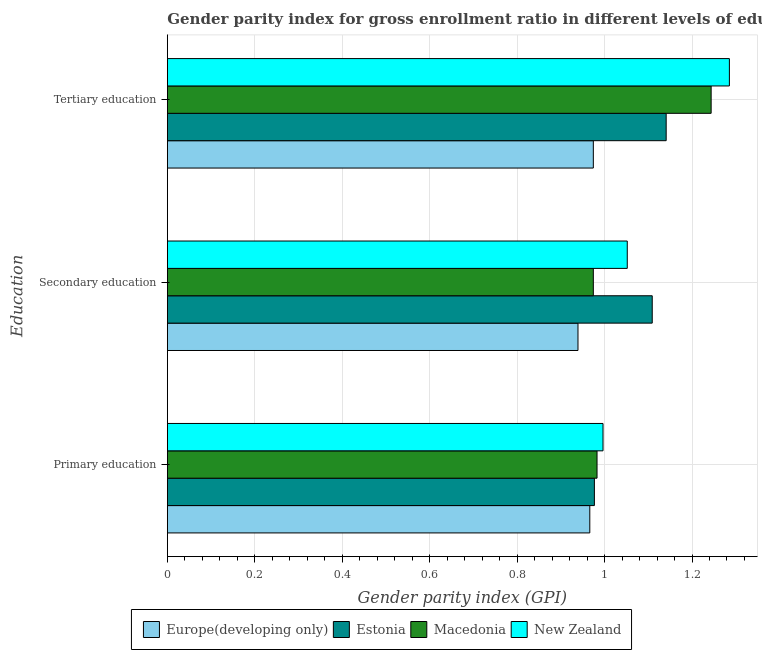Are the number of bars per tick equal to the number of legend labels?
Give a very brief answer. Yes. How many bars are there on the 3rd tick from the top?
Provide a short and direct response. 4. How many bars are there on the 1st tick from the bottom?
Your response must be concise. 4. What is the label of the 2nd group of bars from the top?
Give a very brief answer. Secondary education. What is the gender parity index in tertiary education in New Zealand?
Your response must be concise. 1.29. Across all countries, what is the maximum gender parity index in secondary education?
Your answer should be compact. 1.11. Across all countries, what is the minimum gender parity index in tertiary education?
Give a very brief answer. 0.97. In which country was the gender parity index in primary education maximum?
Provide a short and direct response. New Zealand. In which country was the gender parity index in secondary education minimum?
Your answer should be compact. Europe(developing only). What is the total gender parity index in primary education in the graph?
Provide a succinct answer. 3.92. What is the difference between the gender parity index in tertiary education in Estonia and that in New Zealand?
Ensure brevity in your answer.  -0.14. What is the difference between the gender parity index in primary education in Macedonia and the gender parity index in secondary education in Estonia?
Give a very brief answer. -0.13. What is the average gender parity index in secondary education per country?
Offer a terse response. 1.02. What is the difference between the gender parity index in secondary education and gender parity index in primary education in Estonia?
Give a very brief answer. 0.13. What is the ratio of the gender parity index in primary education in Europe(developing only) to that in Macedonia?
Ensure brevity in your answer.  0.98. Is the gender parity index in tertiary education in Estonia less than that in New Zealand?
Give a very brief answer. Yes. What is the difference between the highest and the second highest gender parity index in primary education?
Your answer should be compact. 0.01. What is the difference between the highest and the lowest gender parity index in tertiary education?
Offer a terse response. 0.31. In how many countries, is the gender parity index in tertiary education greater than the average gender parity index in tertiary education taken over all countries?
Provide a succinct answer. 2. Is the sum of the gender parity index in secondary education in Europe(developing only) and Estonia greater than the maximum gender parity index in primary education across all countries?
Give a very brief answer. Yes. What does the 2nd bar from the top in Tertiary education represents?
Provide a succinct answer. Macedonia. What does the 1st bar from the bottom in Tertiary education represents?
Your answer should be very brief. Europe(developing only). Is it the case that in every country, the sum of the gender parity index in primary education and gender parity index in secondary education is greater than the gender parity index in tertiary education?
Your answer should be compact. Yes. How many countries are there in the graph?
Your answer should be compact. 4. What is the difference between two consecutive major ticks on the X-axis?
Keep it short and to the point. 0.2. Are the values on the major ticks of X-axis written in scientific E-notation?
Your answer should be very brief. No. Does the graph contain grids?
Make the answer very short. Yes. How are the legend labels stacked?
Provide a succinct answer. Horizontal. What is the title of the graph?
Make the answer very short. Gender parity index for gross enrollment ratio in different levels of education in 1996. What is the label or title of the X-axis?
Offer a very short reply. Gender parity index (GPI). What is the label or title of the Y-axis?
Ensure brevity in your answer.  Education. What is the Gender parity index (GPI) of Europe(developing only) in Primary education?
Your answer should be very brief. 0.97. What is the Gender parity index (GPI) of Estonia in Primary education?
Ensure brevity in your answer.  0.98. What is the Gender parity index (GPI) of Macedonia in Primary education?
Keep it short and to the point. 0.98. What is the Gender parity index (GPI) of New Zealand in Primary education?
Ensure brevity in your answer.  1. What is the Gender parity index (GPI) of Europe(developing only) in Secondary education?
Your response must be concise. 0.94. What is the Gender parity index (GPI) in Estonia in Secondary education?
Give a very brief answer. 1.11. What is the Gender parity index (GPI) in Macedonia in Secondary education?
Provide a succinct answer. 0.97. What is the Gender parity index (GPI) of New Zealand in Secondary education?
Your response must be concise. 1.05. What is the Gender parity index (GPI) in Europe(developing only) in Tertiary education?
Your response must be concise. 0.97. What is the Gender parity index (GPI) in Estonia in Tertiary education?
Your answer should be compact. 1.14. What is the Gender parity index (GPI) of Macedonia in Tertiary education?
Make the answer very short. 1.24. What is the Gender parity index (GPI) in New Zealand in Tertiary education?
Ensure brevity in your answer.  1.29. Across all Education, what is the maximum Gender parity index (GPI) in Europe(developing only)?
Make the answer very short. 0.97. Across all Education, what is the maximum Gender parity index (GPI) of Estonia?
Offer a very short reply. 1.14. Across all Education, what is the maximum Gender parity index (GPI) in Macedonia?
Offer a terse response. 1.24. Across all Education, what is the maximum Gender parity index (GPI) of New Zealand?
Offer a terse response. 1.29. Across all Education, what is the minimum Gender parity index (GPI) of Europe(developing only)?
Provide a succinct answer. 0.94. Across all Education, what is the minimum Gender parity index (GPI) in Estonia?
Offer a very short reply. 0.98. Across all Education, what is the minimum Gender parity index (GPI) in Macedonia?
Provide a short and direct response. 0.97. Across all Education, what is the minimum Gender parity index (GPI) in New Zealand?
Offer a terse response. 1. What is the total Gender parity index (GPI) in Europe(developing only) in the graph?
Provide a succinct answer. 2.88. What is the total Gender parity index (GPI) of Estonia in the graph?
Provide a short and direct response. 3.23. What is the total Gender parity index (GPI) of Macedonia in the graph?
Keep it short and to the point. 3.2. What is the total Gender parity index (GPI) of New Zealand in the graph?
Ensure brevity in your answer.  3.33. What is the difference between the Gender parity index (GPI) of Europe(developing only) in Primary education and that in Secondary education?
Ensure brevity in your answer.  0.03. What is the difference between the Gender parity index (GPI) in Estonia in Primary education and that in Secondary education?
Give a very brief answer. -0.13. What is the difference between the Gender parity index (GPI) of Macedonia in Primary education and that in Secondary education?
Keep it short and to the point. 0.01. What is the difference between the Gender parity index (GPI) of New Zealand in Primary education and that in Secondary education?
Your answer should be very brief. -0.06. What is the difference between the Gender parity index (GPI) in Europe(developing only) in Primary education and that in Tertiary education?
Keep it short and to the point. -0.01. What is the difference between the Gender parity index (GPI) in Estonia in Primary education and that in Tertiary education?
Your answer should be compact. -0.16. What is the difference between the Gender parity index (GPI) in Macedonia in Primary education and that in Tertiary education?
Ensure brevity in your answer.  -0.26. What is the difference between the Gender parity index (GPI) of New Zealand in Primary education and that in Tertiary education?
Ensure brevity in your answer.  -0.29. What is the difference between the Gender parity index (GPI) in Europe(developing only) in Secondary education and that in Tertiary education?
Your answer should be compact. -0.04. What is the difference between the Gender parity index (GPI) of Estonia in Secondary education and that in Tertiary education?
Offer a very short reply. -0.03. What is the difference between the Gender parity index (GPI) of Macedonia in Secondary education and that in Tertiary education?
Provide a short and direct response. -0.27. What is the difference between the Gender parity index (GPI) of New Zealand in Secondary education and that in Tertiary education?
Offer a terse response. -0.23. What is the difference between the Gender parity index (GPI) in Europe(developing only) in Primary education and the Gender parity index (GPI) in Estonia in Secondary education?
Provide a short and direct response. -0.14. What is the difference between the Gender parity index (GPI) in Europe(developing only) in Primary education and the Gender parity index (GPI) in Macedonia in Secondary education?
Your answer should be compact. -0.01. What is the difference between the Gender parity index (GPI) in Europe(developing only) in Primary education and the Gender parity index (GPI) in New Zealand in Secondary education?
Offer a very short reply. -0.09. What is the difference between the Gender parity index (GPI) in Estonia in Primary education and the Gender parity index (GPI) in Macedonia in Secondary education?
Give a very brief answer. 0. What is the difference between the Gender parity index (GPI) of Estonia in Primary education and the Gender parity index (GPI) of New Zealand in Secondary education?
Ensure brevity in your answer.  -0.08. What is the difference between the Gender parity index (GPI) in Macedonia in Primary education and the Gender parity index (GPI) in New Zealand in Secondary education?
Offer a terse response. -0.07. What is the difference between the Gender parity index (GPI) of Europe(developing only) in Primary education and the Gender parity index (GPI) of Estonia in Tertiary education?
Make the answer very short. -0.17. What is the difference between the Gender parity index (GPI) in Europe(developing only) in Primary education and the Gender parity index (GPI) in Macedonia in Tertiary education?
Provide a short and direct response. -0.28. What is the difference between the Gender parity index (GPI) of Europe(developing only) in Primary education and the Gender parity index (GPI) of New Zealand in Tertiary education?
Provide a succinct answer. -0.32. What is the difference between the Gender parity index (GPI) of Estonia in Primary education and the Gender parity index (GPI) of Macedonia in Tertiary education?
Your answer should be compact. -0.27. What is the difference between the Gender parity index (GPI) of Estonia in Primary education and the Gender parity index (GPI) of New Zealand in Tertiary education?
Keep it short and to the point. -0.31. What is the difference between the Gender parity index (GPI) of Macedonia in Primary education and the Gender parity index (GPI) of New Zealand in Tertiary education?
Your answer should be very brief. -0.3. What is the difference between the Gender parity index (GPI) of Europe(developing only) in Secondary education and the Gender parity index (GPI) of Estonia in Tertiary education?
Give a very brief answer. -0.2. What is the difference between the Gender parity index (GPI) of Europe(developing only) in Secondary education and the Gender parity index (GPI) of Macedonia in Tertiary education?
Offer a terse response. -0.3. What is the difference between the Gender parity index (GPI) of Europe(developing only) in Secondary education and the Gender parity index (GPI) of New Zealand in Tertiary education?
Keep it short and to the point. -0.35. What is the difference between the Gender parity index (GPI) in Estonia in Secondary education and the Gender parity index (GPI) in Macedonia in Tertiary education?
Make the answer very short. -0.13. What is the difference between the Gender parity index (GPI) of Estonia in Secondary education and the Gender parity index (GPI) of New Zealand in Tertiary education?
Offer a terse response. -0.18. What is the difference between the Gender parity index (GPI) in Macedonia in Secondary education and the Gender parity index (GPI) in New Zealand in Tertiary education?
Your answer should be very brief. -0.31. What is the average Gender parity index (GPI) in Europe(developing only) per Education?
Offer a terse response. 0.96. What is the average Gender parity index (GPI) of Estonia per Education?
Give a very brief answer. 1.08. What is the average Gender parity index (GPI) of Macedonia per Education?
Offer a terse response. 1.07. What is the average Gender parity index (GPI) of New Zealand per Education?
Provide a short and direct response. 1.11. What is the difference between the Gender parity index (GPI) of Europe(developing only) and Gender parity index (GPI) of Estonia in Primary education?
Offer a very short reply. -0.01. What is the difference between the Gender parity index (GPI) of Europe(developing only) and Gender parity index (GPI) of Macedonia in Primary education?
Ensure brevity in your answer.  -0.02. What is the difference between the Gender parity index (GPI) in Europe(developing only) and Gender parity index (GPI) in New Zealand in Primary education?
Keep it short and to the point. -0.03. What is the difference between the Gender parity index (GPI) in Estonia and Gender parity index (GPI) in Macedonia in Primary education?
Keep it short and to the point. -0.01. What is the difference between the Gender parity index (GPI) of Estonia and Gender parity index (GPI) of New Zealand in Primary education?
Keep it short and to the point. -0.02. What is the difference between the Gender parity index (GPI) in Macedonia and Gender parity index (GPI) in New Zealand in Primary education?
Offer a terse response. -0.01. What is the difference between the Gender parity index (GPI) of Europe(developing only) and Gender parity index (GPI) of Estonia in Secondary education?
Your response must be concise. -0.17. What is the difference between the Gender parity index (GPI) in Europe(developing only) and Gender parity index (GPI) in Macedonia in Secondary education?
Give a very brief answer. -0.04. What is the difference between the Gender parity index (GPI) of Europe(developing only) and Gender parity index (GPI) of New Zealand in Secondary education?
Keep it short and to the point. -0.11. What is the difference between the Gender parity index (GPI) in Estonia and Gender parity index (GPI) in Macedonia in Secondary education?
Your answer should be very brief. 0.13. What is the difference between the Gender parity index (GPI) of Estonia and Gender parity index (GPI) of New Zealand in Secondary education?
Offer a very short reply. 0.06. What is the difference between the Gender parity index (GPI) of Macedonia and Gender parity index (GPI) of New Zealand in Secondary education?
Your answer should be compact. -0.08. What is the difference between the Gender parity index (GPI) of Europe(developing only) and Gender parity index (GPI) of Estonia in Tertiary education?
Keep it short and to the point. -0.17. What is the difference between the Gender parity index (GPI) of Europe(developing only) and Gender parity index (GPI) of Macedonia in Tertiary education?
Provide a succinct answer. -0.27. What is the difference between the Gender parity index (GPI) of Europe(developing only) and Gender parity index (GPI) of New Zealand in Tertiary education?
Make the answer very short. -0.31. What is the difference between the Gender parity index (GPI) of Estonia and Gender parity index (GPI) of Macedonia in Tertiary education?
Provide a succinct answer. -0.1. What is the difference between the Gender parity index (GPI) in Estonia and Gender parity index (GPI) in New Zealand in Tertiary education?
Your answer should be compact. -0.14. What is the difference between the Gender parity index (GPI) in Macedonia and Gender parity index (GPI) in New Zealand in Tertiary education?
Make the answer very short. -0.04. What is the ratio of the Gender parity index (GPI) of Europe(developing only) in Primary education to that in Secondary education?
Make the answer very short. 1.03. What is the ratio of the Gender parity index (GPI) of Estonia in Primary education to that in Secondary education?
Your answer should be compact. 0.88. What is the ratio of the Gender parity index (GPI) in Macedonia in Primary education to that in Secondary education?
Ensure brevity in your answer.  1.01. What is the ratio of the Gender parity index (GPI) of New Zealand in Primary education to that in Secondary education?
Provide a short and direct response. 0.95. What is the ratio of the Gender parity index (GPI) of Estonia in Primary education to that in Tertiary education?
Your answer should be compact. 0.86. What is the ratio of the Gender parity index (GPI) in Macedonia in Primary education to that in Tertiary education?
Ensure brevity in your answer.  0.79. What is the ratio of the Gender parity index (GPI) of New Zealand in Primary education to that in Tertiary education?
Your answer should be compact. 0.78. What is the ratio of the Gender parity index (GPI) in Estonia in Secondary education to that in Tertiary education?
Ensure brevity in your answer.  0.97. What is the ratio of the Gender parity index (GPI) of Macedonia in Secondary education to that in Tertiary education?
Make the answer very short. 0.78. What is the ratio of the Gender parity index (GPI) of New Zealand in Secondary education to that in Tertiary education?
Offer a terse response. 0.82. What is the difference between the highest and the second highest Gender parity index (GPI) in Europe(developing only)?
Offer a very short reply. 0.01. What is the difference between the highest and the second highest Gender parity index (GPI) in Estonia?
Offer a very short reply. 0.03. What is the difference between the highest and the second highest Gender parity index (GPI) in Macedonia?
Ensure brevity in your answer.  0.26. What is the difference between the highest and the second highest Gender parity index (GPI) in New Zealand?
Give a very brief answer. 0.23. What is the difference between the highest and the lowest Gender parity index (GPI) in Europe(developing only)?
Offer a terse response. 0.04. What is the difference between the highest and the lowest Gender parity index (GPI) of Estonia?
Your answer should be compact. 0.16. What is the difference between the highest and the lowest Gender parity index (GPI) of Macedonia?
Keep it short and to the point. 0.27. What is the difference between the highest and the lowest Gender parity index (GPI) in New Zealand?
Offer a terse response. 0.29. 